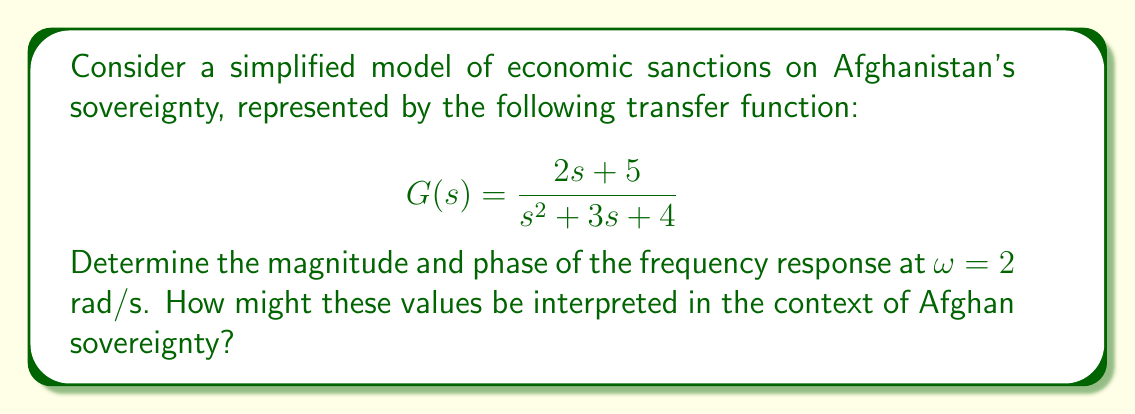Could you help me with this problem? To evaluate the frequency response, we need to calculate the magnitude and phase of G(jω) at ω = 2 rad/s.

1. Substitute s with jω in G(s):
   $$G(jω) = \frac{2(jω) + 5}{(jω)^2 + 3(jω) + 4}$$

2. At ω = 2, we have:
   $$G(j2) = \frac{2(j2) + 5}{(j2)^2 + 3(j2) + 4} = \frac{4j + 5}{-4 + 6j + 4} = \frac{4j + 5}{6j}$$

3. Multiply numerator and denominator by the complex conjugate of the denominator:
   $$G(j2) = \frac{(4j + 5)(6j)}{(6j)(6j)} = \frac{24j^2 + 30j}{36j^2} = \frac{-24 + 30j}{-36} = \frac{2}{3} - \frac{5j}{6}$$

4. Calculate the magnitude:
   $$|G(j2)| = \sqrt{(\frac{2}{3})^2 + (-\frac{5}{6})^2} = \sqrt{\frac{4}{9} + \frac{25}{36}} = \sqrt{\frac{41}{36}} \approx 1.0677$$

5. Calculate the phase:
   $$\angle G(j2) = \tan^{-1}(\frac{-5/6}{2/3}) = \tan^{-1}(-1.25) \approx -0.8961 \text{ radians} \approx -51.34°$$

Interpretation:
The magnitude of 1.0677 indicates a slight amplification of the input at this frequency, suggesting that economic sanctions might have a marginally increased effect on Afghan sovereignty at this particular rate of change.

The phase of -51.34° represents a lag between the application of sanctions and their impact on sovereignty, implying a delayed response in the system. This could be interpreted as the time it takes for economic sanctions to manifest their effects on Afghan sovereignty.
Answer: Magnitude: $|G(j2)| \approx 1.0677$
Phase: $\angle G(j2) \approx -0.8961 \text{ radians} \approx -51.34°$ 